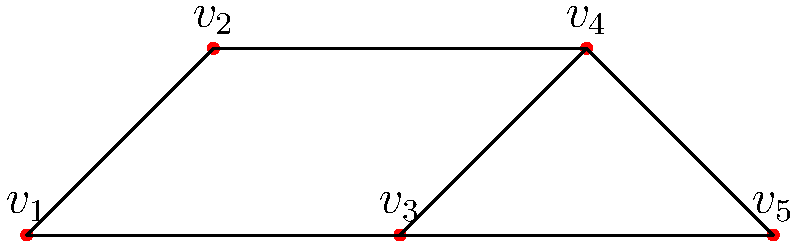In a network of film distributors and theaters represented by the graph above, vertices represent major cities and edges represent direct distribution channels. What is the minimum number of distribution channels (edges) that need to be removed to disconnect the network into two or more components? To solve this problem, we need to find the edge connectivity of the graph. The edge connectivity is the minimum number of edges that, when removed, disconnect the graph. This concept is crucial for understanding the resilience of distribution networks in the film industry.

Step 1: Identify all possible paths between vertices.
There are multiple paths between most pairs of vertices, indicating some level of redundancy in the network.

Step 2: Look for the minimum cut set.
A cut set is a set of edges that, when removed, disconnects the graph. We need to find the smallest such set.

Step 3: Analyze potential cut sets:
- Removing edge $(v_1, v_2)$ and $(v_1, v_3)$ disconnects $v_1$ from the rest of the graph.
- Removing edge $(v_2, v_4)$ and $(v_3, v_4)$ disconnects $v_5$ from the rest of the graph.
- Removing edge $(v_2, v_3)$, $(v_2, v_4)$, and $(v_3, v_4)$ disconnects the graph into two components.

Step 4: Determine the minimum cut set.
The minimum cut set contains two edges: either $(v_1, v_2)$ and $(v_1, v_3)$, or $(v_2, v_4)$ and $(v_3, v_4)$.

Therefore, the edge connectivity of this graph is 2, meaning at least 2 distribution channels need to be removed to disconnect the network.
Answer: 2 